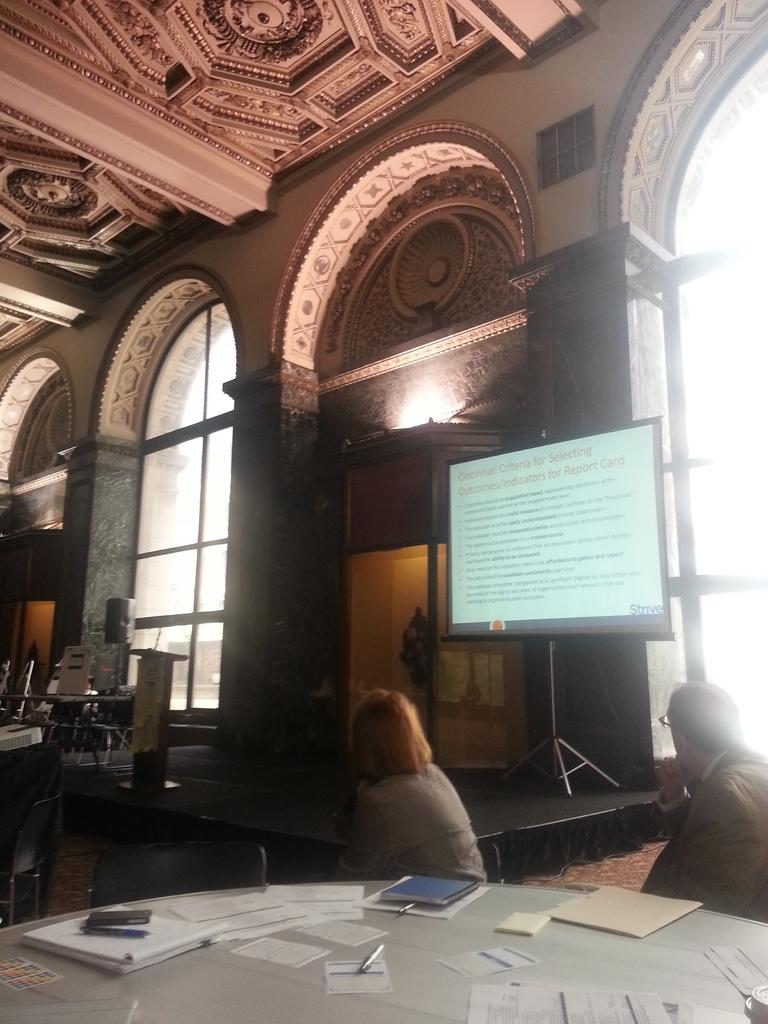How many people are in the image? There are two persons in the image. What are the two persons doing in the image? The two persons are sitting in a chair. What is in front of the two persons? There is a table in front of the two persons. What are the two persons watching? The two persons are watching an LED screen. Where is the LED screen located? The LED screen is on the wall. What type of ball is being used to play a game on the table? There is no ball present in the image, and no game is being played on the table. 